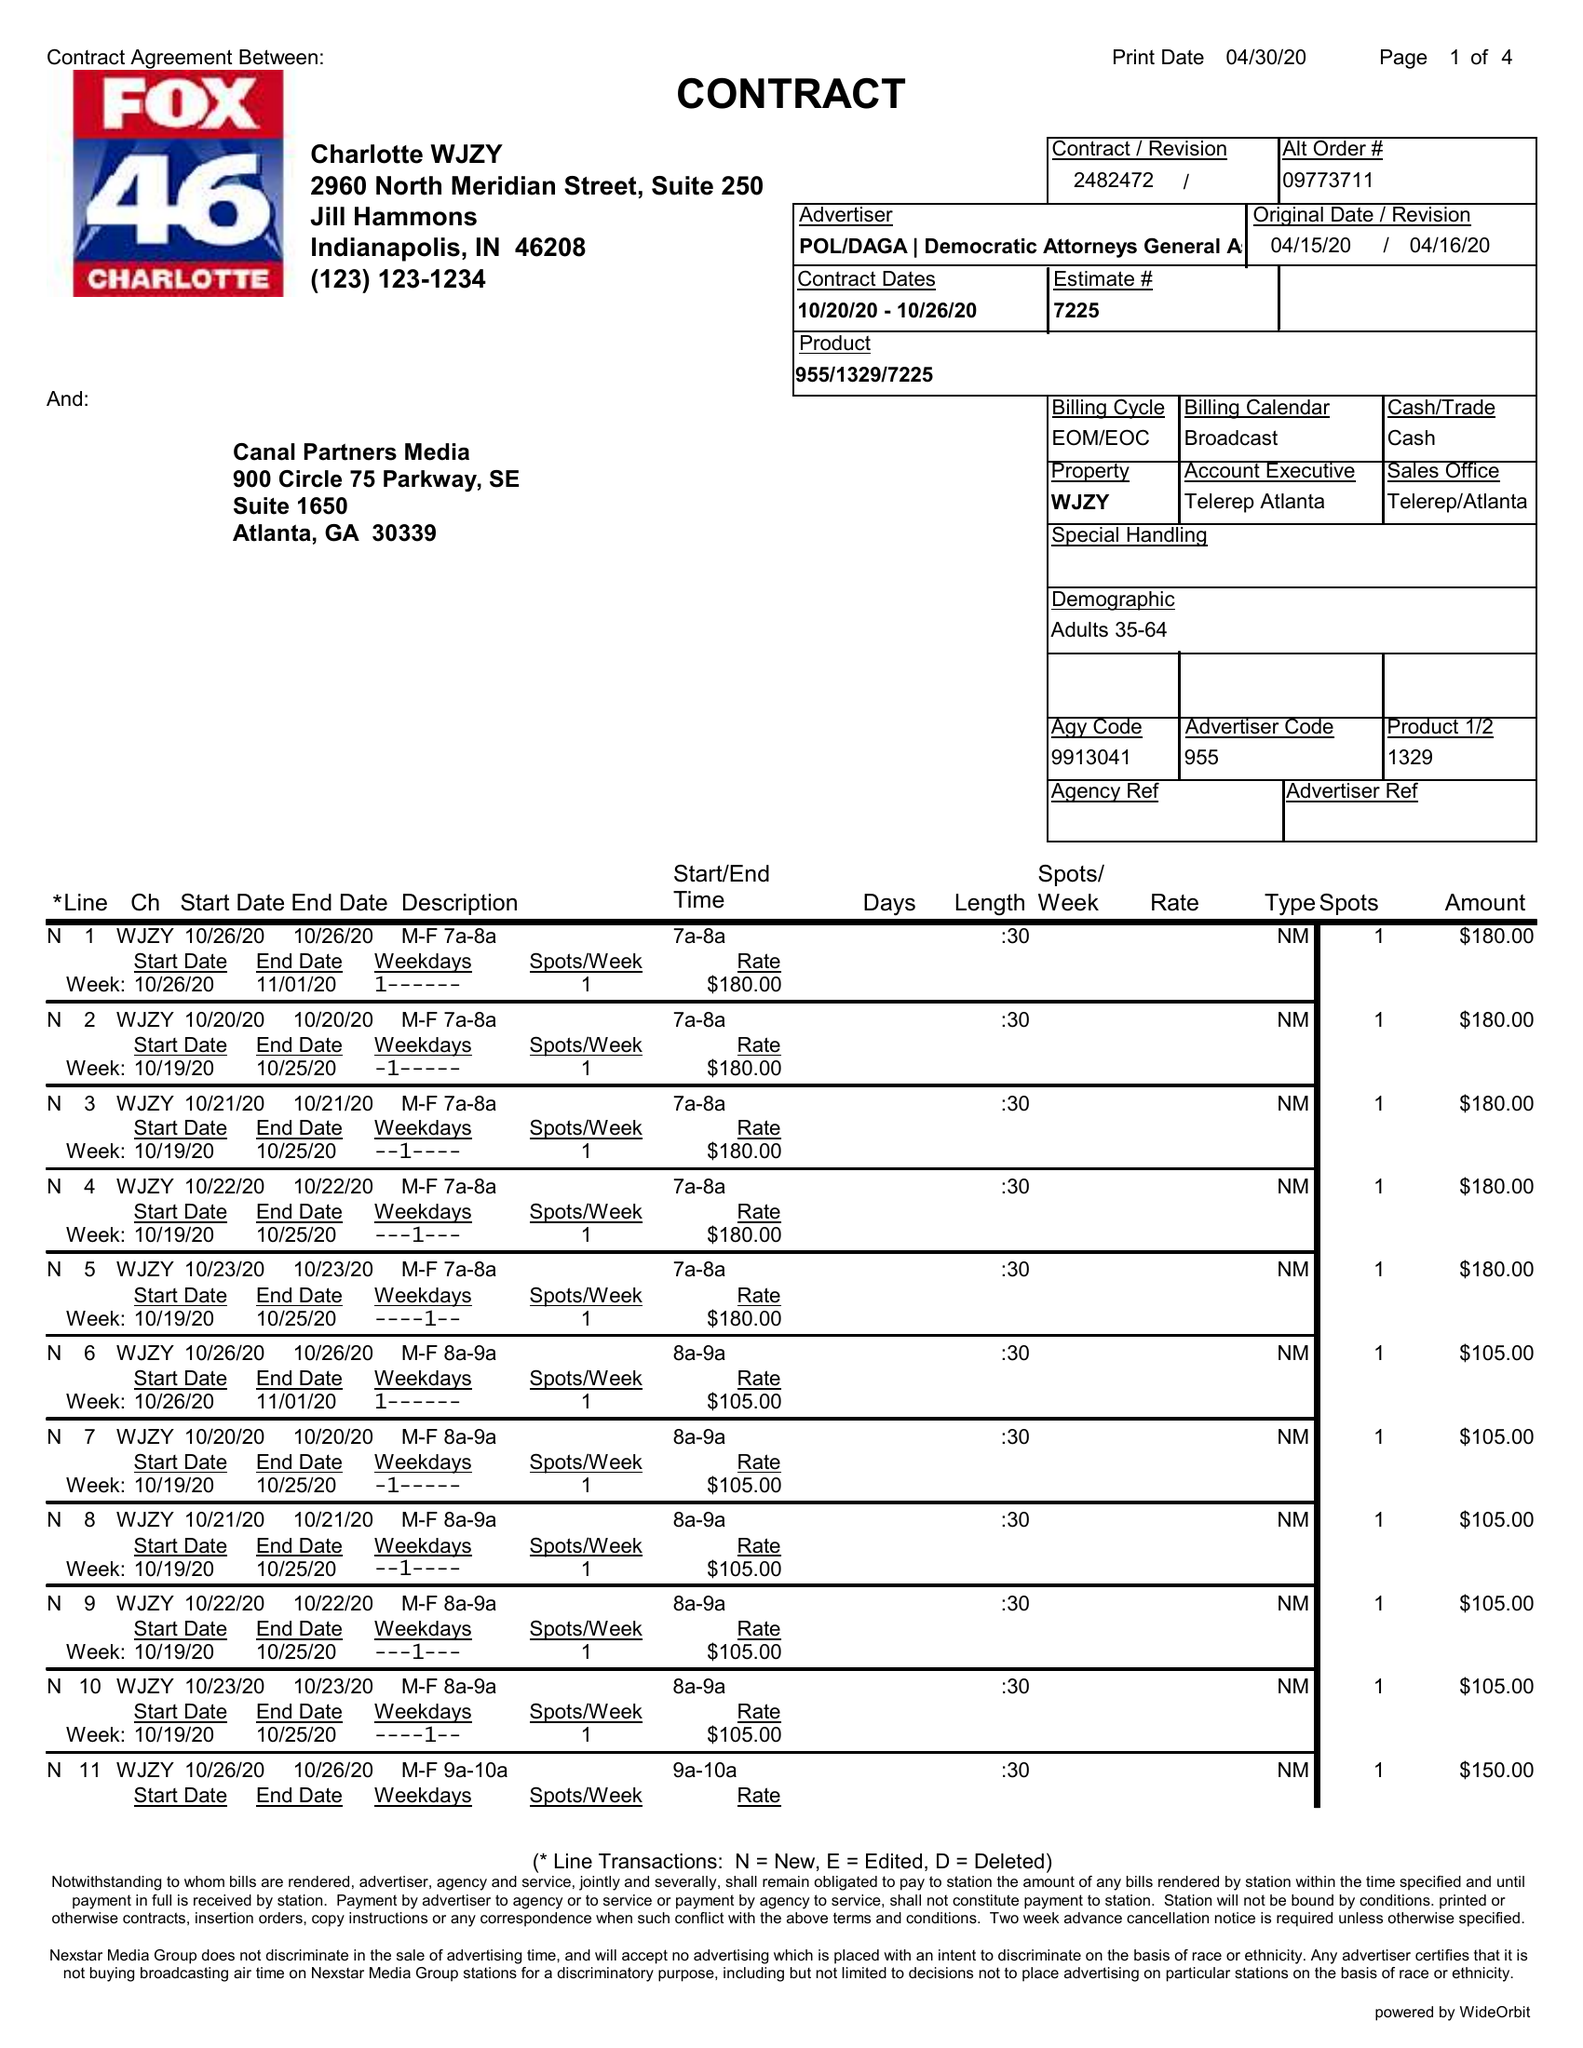What is the value for the advertiser?
Answer the question using a single word or phrase. POL/DAGA|DEMOCRATICATTORNEYSGENERALASSOCPAC 